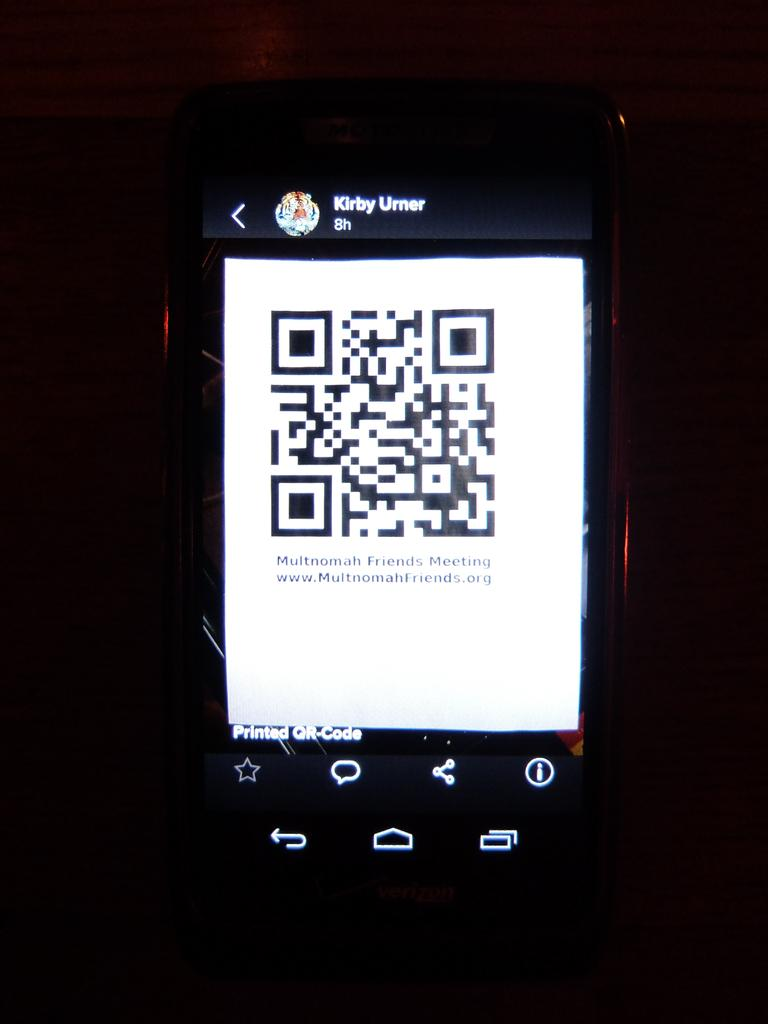<image>
Present a compact description of the photo's key features. Kriby Ulmer's electronic device showing a QR code on the screen. 